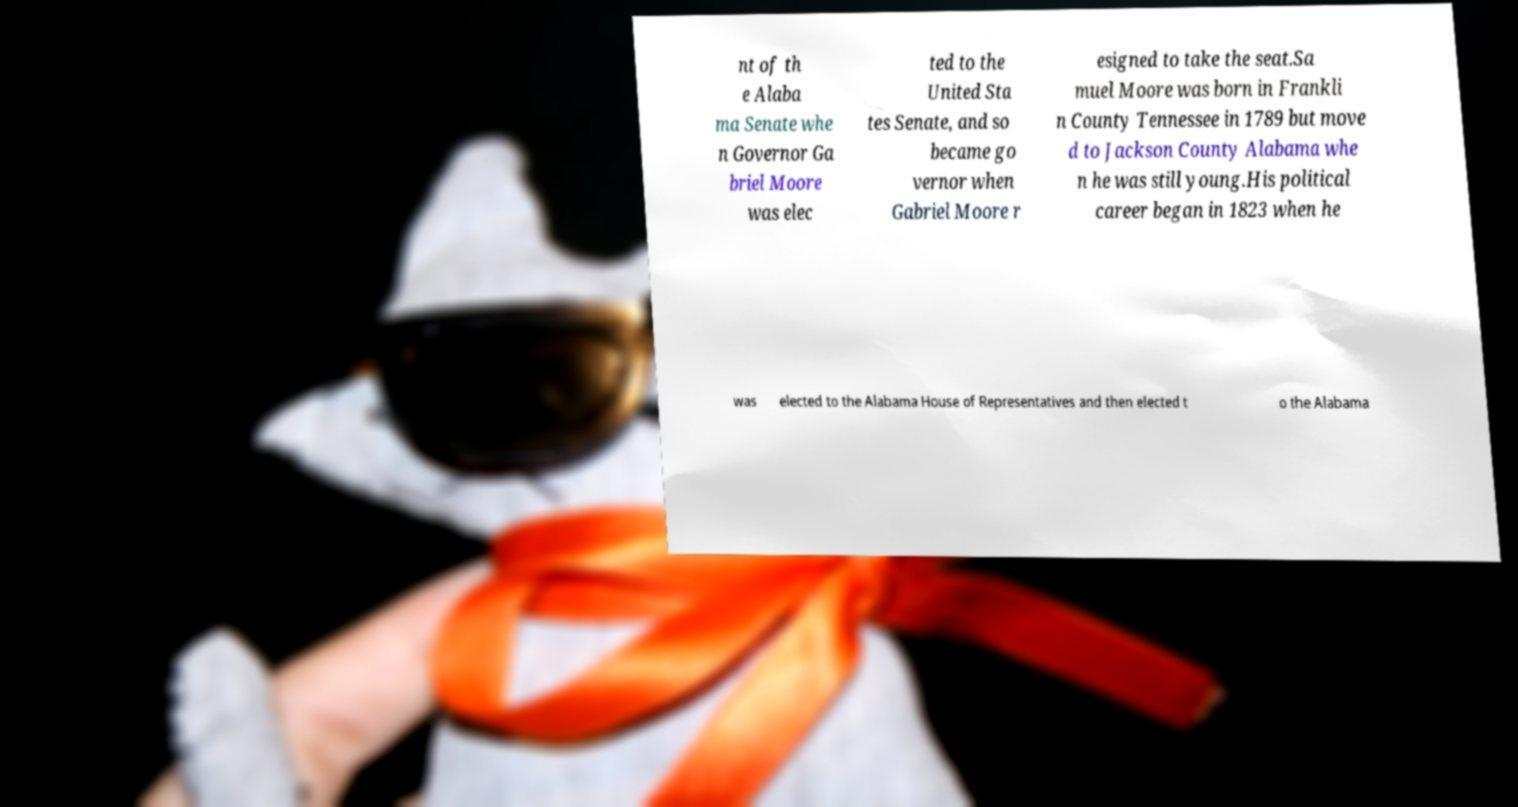Please read and relay the text visible in this image. What does it say? nt of th e Alaba ma Senate whe n Governor Ga briel Moore was elec ted to the United Sta tes Senate, and so became go vernor when Gabriel Moore r esigned to take the seat.Sa muel Moore was born in Frankli n County Tennessee in 1789 but move d to Jackson County Alabama whe n he was still young.His political career began in 1823 when he was elected to the Alabama House of Representatives and then elected t o the Alabama 